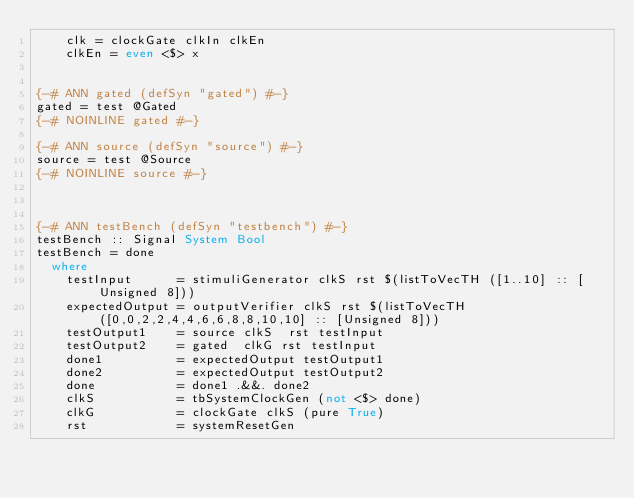Convert code to text. <code><loc_0><loc_0><loc_500><loc_500><_Haskell_>    clk = clockGate clkIn clkEn
    clkEn = even <$> x


{-# ANN gated (defSyn "gated") #-}
gated = test @Gated
{-# NOINLINE gated #-}

{-# ANN source (defSyn "source") #-}
source = test @Source
{-# NOINLINE source #-}



{-# ANN testBench (defSyn "testbench") #-}
testBench :: Signal System Bool
testBench = done
  where
    testInput      = stimuliGenerator clkS rst $(listToVecTH ([1..10] :: [Unsigned 8]))
    expectedOutput = outputVerifier clkS rst $(listToVecTH ([0,0,2,2,4,4,6,6,8,8,10,10] :: [Unsigned 8]))
    testOutput1    = source clkS  rst testInput
    testOutput2    = gated  clkG rst testInput
    done1          = expectedOutput testOutput1
    done2          = expectedOutput testOutput2
    done           = done1 .&&. done2
    clkS           = tbSystemClockGen (not <$> done)
    clkG           = clockGate clkS (pure True)
    rst            = systemResetGen
</code> 